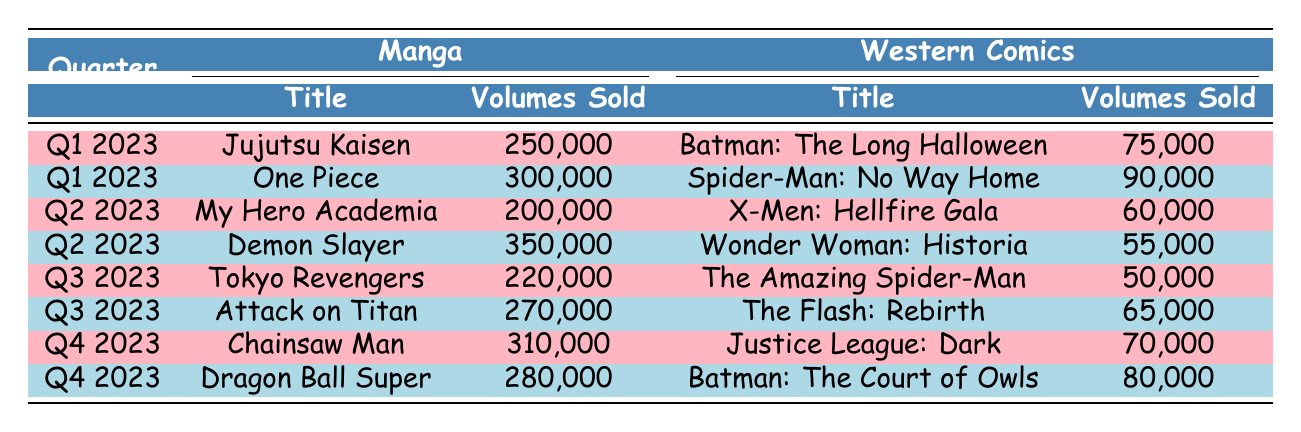What was the highest selling manga title in Q2 2023? The highest selling manga in Q2 2023 is "Demon Slayer" with 350,000 volumes sold. In the table, we can see the volumes sold for each manga title in Q2 2023 and determine that "Demon Slayer" is the highest.
Answer: Demon Slayer How many volumes of "Jujutsu Kaisen" were sold in Q1 2023? In Q1 2023, "Jujutsu Kaisen" sold 250,000 volumes, as stated directly in the table under the manga section for that quarter.
Answer: 250,000 What is the difference in volumes sold between "One Piece" and "Spider-Man: No Way Home" in Q1 2023? "One Piece" sold 300,000 volumes and "Spider-Man: No Way Home" sold 90,000 volumes in Q1 2023. To find the difference, we subtract: 300,000 - 90,000 = 210,000.
Answer: 210,000 Which western comic had the lowest sales in Q2 2023? In Q2 2023, "Wonder Woman: Historia" sold 55,000 volumes, which is the lowest compared to "X-Men: Hellfire Gala" that sold 60,000 volumes, as seen in the table.
Answer: Wonder Woman: Historia What was the total volume sales of manga in Q3 2023? In Q3 2023, "Tokyo Revengers" sold 220,000 volumes and "Attack on Titan" sold 270,000 volumes. We add these volumes together: 220,000 + 270,000 = 490,000.
Answer: 490,000 Is it true or false that "Chainsaw Man" sold more than any western comic in Q4 2023? In Q4 2023, "Chainsaw Man" sold 310,000 volumes, while the highest selling western comic, "Batman: The Court of Owls", sold 80,000 volumes. Since 310,000 is greater than 80,000, the statement is true.
Answer: True What is the average volume sold for the manga titles across all four quarters? The total volumes sold for the manga titles are 250,000 + 300,000 + 200,000 + 350,000 + 220,000 + 270,000 + 310,000 + 280,000 = 1,980,000. There are 8 data points, so the average is 1,980,000 / 8 = 247,500.
Answer: 247,500 Which quarter had the highest total sales for western comics? Examining the sales for western comics: Q1 2023 total is 75,000 + 90,000 = 165,000; Q2 2023 total is 60,000 + 55,000 = 115,000; Q3 2023 total is 50,000 + 65,000 = 115,000; Q4 2023 total is 70,000 + 80,000 = 150,000. The highest is Q1 2023 with 165,000.
Answer: Q1 2023 What is the total volume sold for both "Attack on Titan" and "Dragon Ball Super"? "Attack on Titan" sold 270,000 volumes, and "Dragon Ball Super" sold 280,000 volumes. Adding these gives: 270,000 + 280,000 = 550,000.
Answer: 550,000 Which manga title saw the least sales in Q1 2023? In Q1 2023, the sales for "Jujutsu Kaisen" were 250,000 volumes and "One Piece" were 300,000 volumes; therefore, "Jujutsu Kaisen" with 250,000 volumes has the least sales in that quarter.
Answer: Jujutsu Kaisen 